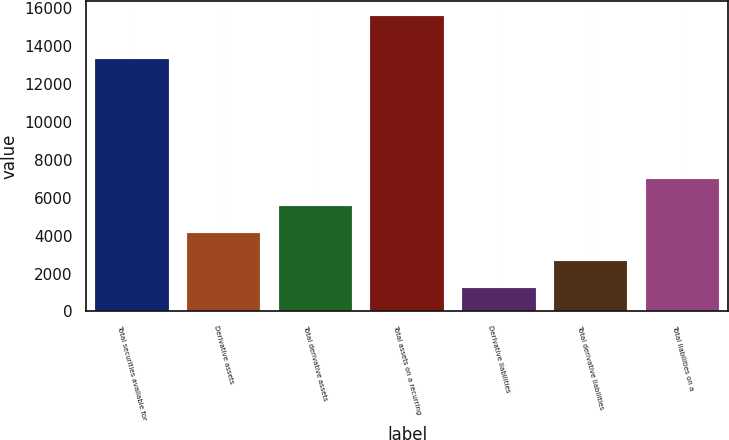Convert chart. <chart><loc_0><loc_0><loc_500><loc_500><bar_chart><fcel>Total securities available for<fcel>Derivative assets<fcel>Total derivative assets<fcel>Total assets on a recurring<fcel>Derivative liabilities<fcel>Total derivative liabilities<fcel>Total liabilities on a<nl><fcel>13328<fcel>4120.8<fcel>5557.2<fcel>15612<fcel>1248<fcel>2684.4<fcel>6993.6<nl></chart> 